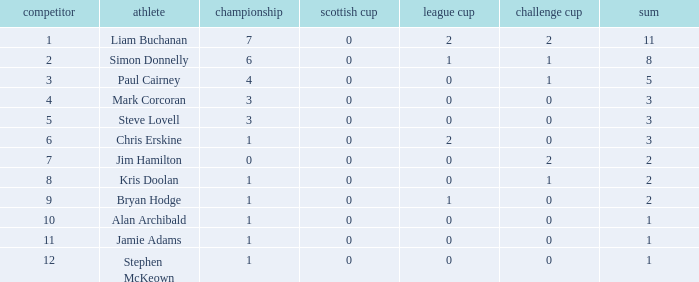What is kris doolan's league digit? 1.0. 